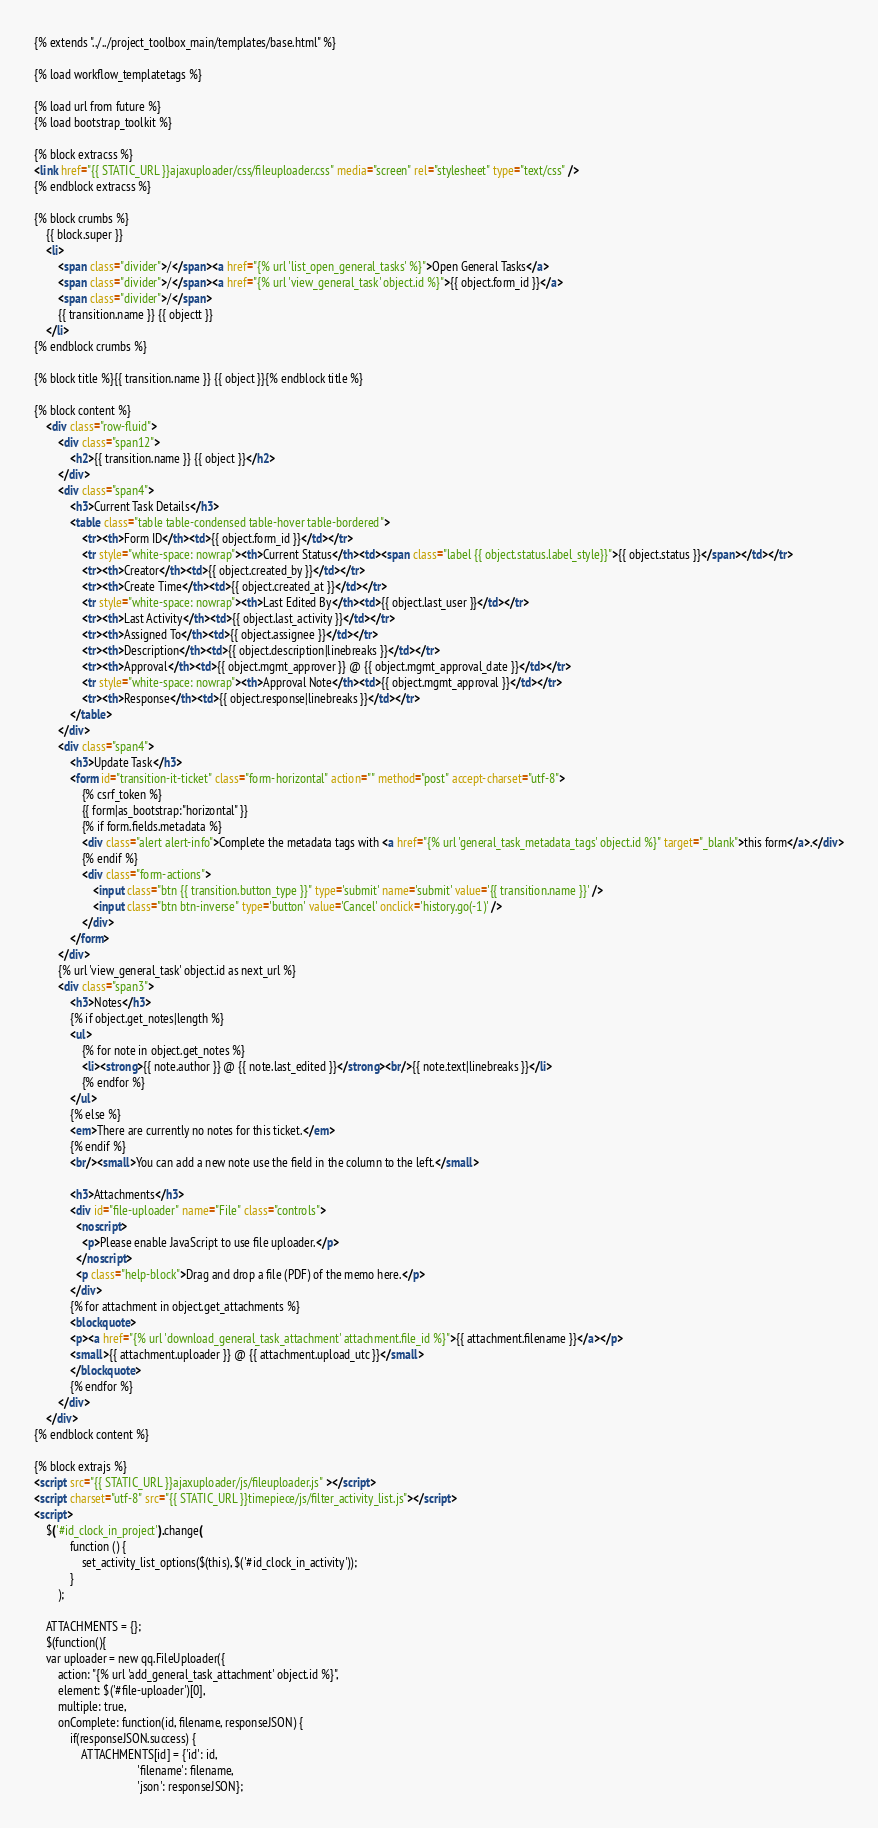<code> <loc_0><loc_0><loc_500><loc_500><_HTML_>{% extends "../../project_toolbox_main/templates/base.html" %}

{% load workflow_templatetags %}

{% load url from future %}
{% load bootstrap_toolkit %}

{% block extracss %}
<link href="{{ STATIC_URL }}ajaxuploader/css/fileuploader.css" media="screen" rel="stylesheet" type="text/css" />
{% endblock extracss %}

{% block crumbs %}
    {{ block.super }}
    <li>
        <span class="divider">/</span><a href="{% url 'list_open_general_tasks' %}">Open General Tasks</a>
        <span class="divider">/</span><a href="{% url 'view_general_task' object.id %}">{{ object.form_id }}</a>
        <span class="divider">/</span>
        {{ transition.name }} {{ objectt }}
    </li>
{% endblock crumbs %}

{% block title %}{{ transition.name }} {{ object }}{% endblock title %}

{% block content %}
    <div class="row-fluid">
        <div class="span12">
            <h2>{{ transition.name }} {{ object }}</h2>
        </div>
        <div class="span4">
            <h3>Current Task Details</h3>
            <table class="table table-condensed table-hover table-bordered">
                <tr><th>Form ID</th><td>{{ object.form_id }}</td></tr>
                <tr style="white-space: nowrap"><th>Current Status</th><td><span class="label {{ object.status.label_style}}">{{ object.status }}</span></td></tr>
                <tr><th>Creator</th><td>{{ object.created_by }}</td></tr>
                <tr><th>Create Time</th><td>{{ object.created_at }}</td></tr>
                <tr style="white-space: nowrap"><th>Last Edited By</th><td>{{ object.last_user }}</td></tr>
                <tr><th>Last Activity</th><td>{{ object.last_activity }}</td></tr>
                <tr><th>Assigned To</th><td>{{ object.assignee }}</td></tr>
                <tr><th>Description</th><td>{{ object.description|linebreaks }}</td></tr>
                <tr><th>Approval</th><td>{{ object.mgmt_approver }} @ {{ object.mgmt_approval_date }}</td></tr>
                <tr style="white-space: nowrap"><th>Approval Note</th><td>{{ object.mgmt_approval }}</td></tr>
                <tr><th>Response</th><td>{{ object.response|linebreaks }}</td></tr>
            </table>
        </div>
        <div class="span4">
            <h3>Update Task</h3>
            <form id="transition-it-ticket" class="form-horizontal" action="" method="post" accept-charset="utf-8">
                {% csrf_token %}
                {{ form|as_bootstrap:"horizontal" }}
                {% if form.fields.metadata %}
                <div class="alert alert-info">Complete the metadata tags with <a href="{% url 'general_task_metadata_tags' object.id %}" target="_blank">this form</a>.</div>
                {% endif %}
                <div class="form-actions">
                    <input class="btn {{ transition.button_type }}" type='submit' name='submit' value='{{ transition.name }}' />
                    <input class="btn btn-inverse" type='button' value='Cancel' onclick='history.go(-1)' />
                </div>
            </form>
        </div>
        {% url 'view_general_task' object.id as next_url %}
        <div class="span3">
            <h3>Notes</h3>
            {% if object.get_notes|length %}
            <ul>
                {% for note in object.get_notes %}
                <li><strong>{{ note.author }} @ {{ note.last_edited }}</strong><br/>{{ note.text|linebreaks }}</li>
                {% endfor %}
            </ul>
            {% else %}
            <em>There are currently no notes for this ticket.</em>
            {% endif %}
            <br/><small>You can add a new note use the field in the column to the left.</small>

            <h3>Attachments</h3>
            <div id="file-uploader" name="File" class="controls">
              <noscript>          
                <p>Please enable JavaScript to use file uploader.</p>
              </noscript>
              <p class="help-block">Drag and drop a file (PDF) of the memo here.</p>
            </div>
            {% for attachment in object.get_attachments %}
            <blockquote>
            <p><a href="{% url 'download_general_task_attachment' attachment.file_id %}">{{ attachment.filename }}</a></p>
            <small>{{ attachment.uploader }} @ {{ attachment.upload_utc }}</small>
            </blockquote>
            {% endfor %}
        </div>
    </div>
{% endblock content %}

{% block extrajs %}
<script src="{{ STATIC_URL }}ajaxuploader/js/fileuploader.js" ></script>
<script charset="utf-8" src="{{ STATIC_URL }}timepiece/js/filter_activity_list.js"></script>
<script>
    $('#id_clock_in_project').change( 
            function () {
                set_activity_list_options($(this), $('#id_clock_in_activity'));
            }
        );

    ATTACHMENTS = {};
    $(function(){
    var uploader = new qq.FileUploader({
        action: "{% url 'add_general_task_attachment' object.id %}",
        element: $('#file-uploader')[0],
        multiple: true,
        onComplete: function(id, filename, responseJSON) {
            if(responseJSON.success) {
                ATTACHMENTS[id] = {'id': id,
                                   'filename': filename,
                                   'json': responseJSON};</code> 